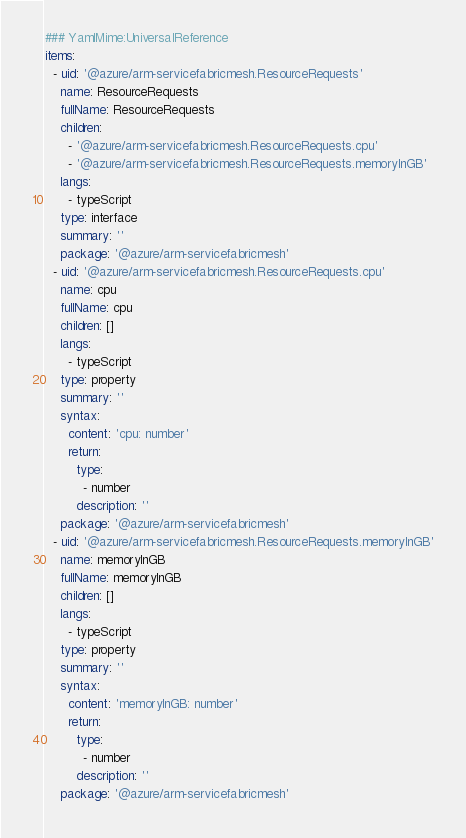Convert code to text. <code><loc_0><loc_0><loc_500><loc_500><_YAML_>### YamlMime:UniversalReference
items:
  - uid: '@azure/arm-servicefabricmesh.ResourceRequests'
    name: ResourceRequests
    fullName: ResourceRequests
    children:
      - '@azure/arm-servicefabricmesh.ResourceRequests.cpu'
      - '@azure/arm-servicefabricmesh.ResourceRequests.memoryInGB'
    langs:
      - typeScript
    type: interface
    summary: ''
    package: '@azure/arm-servicefabricmesh'
  - uid: '@azure/arm-servicefabricmesh.ResourceRequests.cpu'
    name: cpu
    fullName: cpu
    children: []
    langs:
      - typeScript
    type: property
    summary: ''
    syntax:
      content: 'cpu: number'
      return:
        type:
          - number
        description: ''
    package: '@azure/arm-servicefabricmesh'
  - uid: '@azure/arm-servicefabricmesh.ResourceRequests.memoryInGB'
    name: memoryInGB
    fullName: memoryInGB
    children: []
    langs:
      - typeScript
    type: property
    summary: ''
    syntax:
      content: 'memoryInGB: number'
      return:
        type:
          - number
        description: ''
    package: '@azure/arm-servicefabricmesh'
</code> 